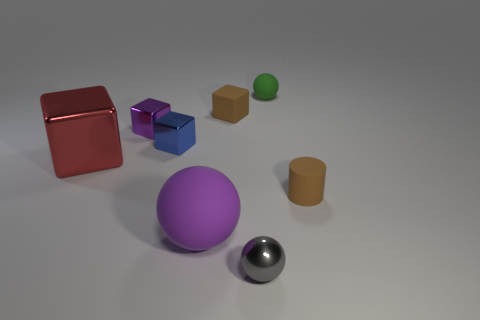What is the material of the block that is the same color as the large sphere?
Ensure brevity in your answer.  Metal. The shiny cube that is the same color as the large matte object is what size?
Ensure brevity in your answer.  Small. There is a small matte object on the left side of the tiny gray shiny object; is it the same color as the small rubber thing in front of the big red thing?
Offer a very short reply. Yes. Is there anything else that has the same color as the matte cylinder?
Your answer should be very brief. Yes. What shape is the red metal thing?
Your response must be concise. Cube. The sphere that is made of the same material as the large red cube is what color?
Offer a terse response. Gray. Are there more tiny rubber cylinders than small cubes?
Your response must be concise. No. Is there a red metal sphere?
Offer a terse response. No. The small rubber thing that is to the left of the tiny shiny object that is in front of the purple sphere is what shape?
Provide a short and direct response. Cube. How many objects are small cyan shiny things or small spheres behind the blue thing?
Provide a short and direct response. 1. 